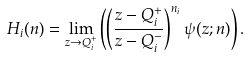Convert formula to latex. <formula><loc_0><loc_0><loc_500><loc_500>H _ { i } ( n ) = \lim _ { z \to Q _ { i } ^ { + } } \left ( \left ( \frac { z - Q _ { i } ^ { + } } { z - Q _ { i } ^ { - } } \right ) ^ { n _ { i } } \psi ( z ; n ) \right ) .</formula> 